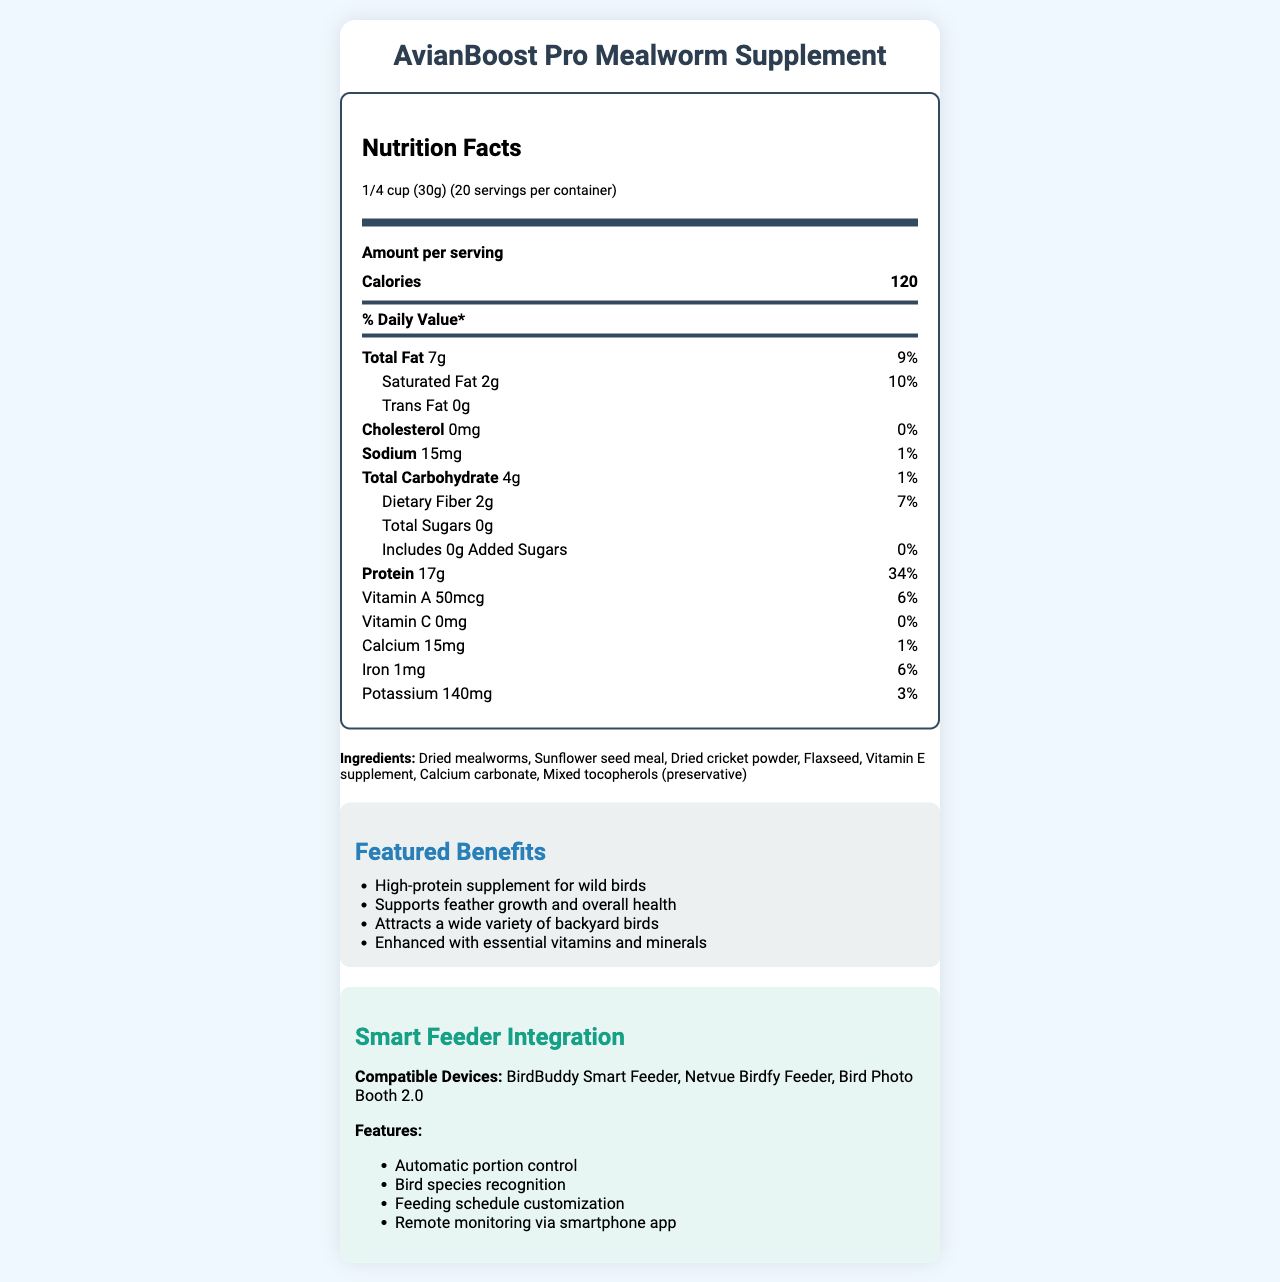what is the serving size? The serving size is clearly mentioned at the top of the Nutrition Facts section as "1/4 cup (30g)".
Answer: 1/4 cup (30g) how many servings are in a container? The document specifies "20 servings per container" next to the serving size information.
Answer: 20 how many calories are in each serving? The calorie information for each serving is listed as "120" right below the Amount per serving section.
Answer: 120 calories what percentage of daily value does protein contribute? The percentage of daily value for protein per serving is indicated as "34%" in the nutrients section.
Answer: 34% which birds might be attracted to this supplement? The bird species attracted by this supplement are listed under "birdSpeciesAttracted".
Answer: American Robin, Eastern Bluebird, Carolina Wren, Northern Cardinal, Tufted Titmouse, Black-capped Chickadee how much total fat is in one serving? The total fat content per serving is listed as "7g" under the total fat section.
Answer: 7g what is in the ingredient list for this supplement? The ingredients are listed under the Ingredients section.
Answer: Dried mealworms, Sunflower seed meal, Dried cricket powder, Flaxseed, Vitamin E supplement, Calcium carbonate, Mixed tocopherols (preservative) which feeder types are compatible with this supplement? The compatible feeders are mentioned under the compatible feeders section.
Answer: Platform feeders, Ground feeding trays, Hopper feeders with large ports how much potassium does one serving contain? The potassium content per serving is specified as "140mg" in the nutrients list.
Answer: 140mg describe the main idea of the document. The main idea of the document is to provide comprehensive details about the AvianBoost Pro Mealworm Supplement, including its nutritional content, benefits, and usage instructions to help attract and nourish backyard birds.
Answer: The document provides detailed nutritional information about the AvianBoost Pro Mealworm Supplement, highlighting its serving size, calorie content, individual nutrient breakdown, ingredients, and benefits. Additionally, it lists the bird species attracted to the supplement, recommended storage tips, feeding instructions, compatible feeders, and smart feeder integration features. what is the cholesterol content per serving? The document lists the cholesterol content in each serving as "0mg".
Answer: 0mg what are some of the featured benefits of this supplement? The featured benefits are clearly mentioned in the "Featured Benefits" section.
Answer: High-protein supplement for wild birds, Supports feather growth and overall health, Attracts a wide variety of backyard birds, Enhanced with essential vitamins and minerals what is the dietary fiber content per serving? The dietary fiber content is specified as "2g" per serving in the nutrients list.
Answer: 2g which of the following devices is not listed as compatible with the smart feeder integration? A. BirdBuddy Smart Feeder B. Netvue Birdfy Feeder C. BirdCam 3.0 D. Bird Photo Booth 2.0 The compatible devices listed are BirdBuddy Smart Feeder, Netvue Birdfy Feeder, and Bird Photo Booth 2.0. BirdCam 3.0 is not mentioned.
Answer: C. BirdCam 3.0 what feeding schedule customization feature is available via the smart feeder app? A. Remote bird watching B. Automatic portion control C. Feeding schedule customization D. In-app bird community The document mentions smart feeder integration features including "Automatic portion control", "Bird species recognition", "Feeding schedule customization", and "Remote monitoring via smartphone app", with feeding schedule customization being one of them.
Answer: C. Feeding schedule customization does the supplement contain any added sugars? The document states that the supplement has "0g" of added sugars.
Answer: No for how long should you use the product after opening? The storage tips section advises to "Use within 6 months of opening".
Answer: Within 6 months how much vitamin C does one serving contain? The document specifies the vitamin C content per serving as "0mg".
Answer: 0mg is it recommended to offer this supplement daily? According to the feeding instructions, it is recommended to "Offer daily, especially during nesting and molting seasons".
Answer: Yes how does this supplement support feather growth? Although the document mentions that the supplement "Supports feather growth and overall health", it does not provide specific details on how the supplement achieves this.
Answer: Not enough information 